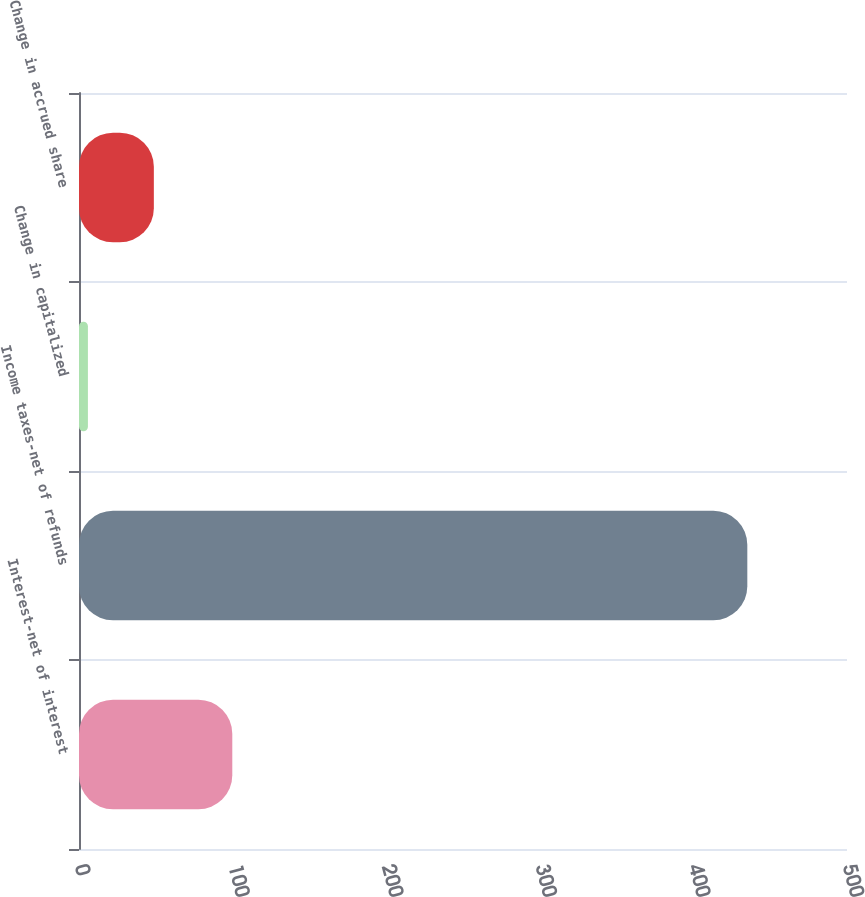Convert chart. <chart><loc_0><loc_0><loc_500><loc_500><bar_chart><fcel>Interest-net of interest<fcel>Income taxes-net of refunds<fcel>Change in capitalized<fcel>Change in accrued share<nl><fcel>99.8<fcel>435.1<fcel>5.8<fcel>48.73<nl></chart> 